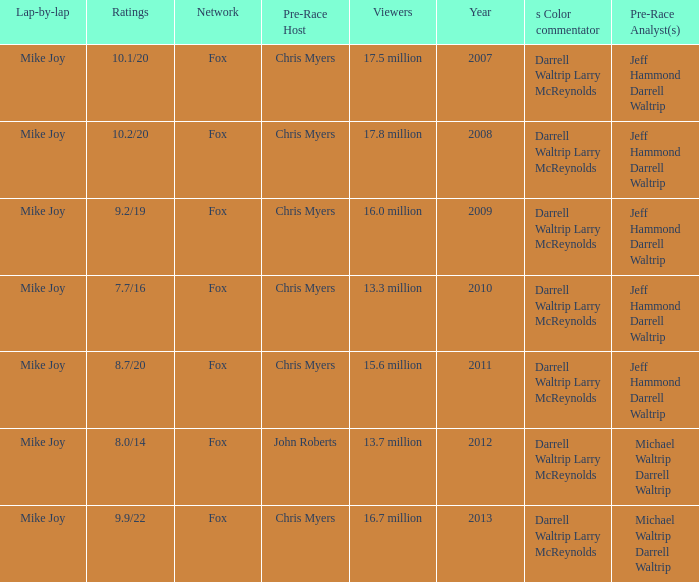Which Network has 16.0 million Viewers? Fox. Write the full table. {'header': ['Lap-by-lap', 'Ratings', 'Network', 'Pre-Race Host', 'Viewers', 'Year', 's Color commentator', 'Pre-Race Analyst(s)'], 'rows': [['Mike Joy', '10.1/20', 'Fox', 'Chris Myers', '17.5 million', '2007', 'Darrell Waltrip Larry McReynolds', 'Jeff Hammond Darrell Waltrip'], ['Mike Joy', '10.2/20', 'Fox', 'Chris Myers', '17.8 million', '2008', 'Darrell Waltrip Larry McReynolds', 'Jeff Hammond Darrell Waltrip'], ['Mike Joy', '9.2/19', 'Fox', 'Chris Myers', '16.0 million', '2009', 'Darrell Waltrip Larry McReynolds', 'Jeff Hammond Darrell Waltrip'], ['Mike Joy', '7.7/16', 'Fox', 'Chris Myers', '13.3 million', '2010', 'Darrell Waltrip Larry McReynolds', 'Jeff Hammond Darrell Waltrip'], ['Mike Joy', '8.7/20', 'Fox', 'Chris Myers', '15.6 million', '2011', 'Darrell Waltrip Larry McReynolds', 'Jeff Hammond Darrell Waltrip'], ['Mike Joy', '8.0/14', 'Fox', 'John Roberts', '13.7 million', '2012', 'Darrell Waltrip Larry McReynolds', 'Michael Waltrip Darrell Waltrip'], ['Mike Joy', '9.9/22', 'Fox', 'Chris Myers', '16.7 million', '2013', 'Darrell Waltrip Larry McReynolds', 'Michael Waltrip Darrell Waltrip']]} 